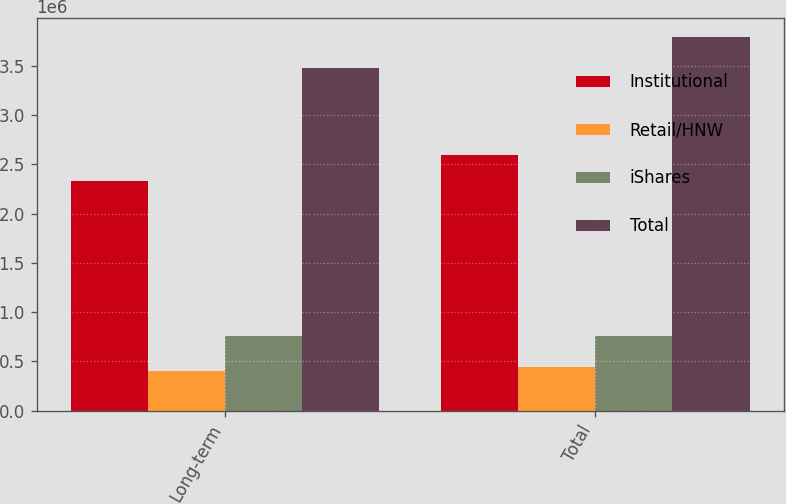Convert chart to OTSL. <chart><loc_0><loc_0><loc_500><loc_500><stacked_bar_chart><ecel><fcel>Long-term<fcel>Total<nl><fcel>Institutional<fcel>2.32618e+06<fcel>2.59309e+06<nl><fcel>Retail/HNW<fcel>403484<fcel>445793<nl><fcel>iShares<fcel>752707<fcel>752707<nl><fcel>Total<fcel>3.48237e+06<fcel>3.79159e+06<nl></chart> 